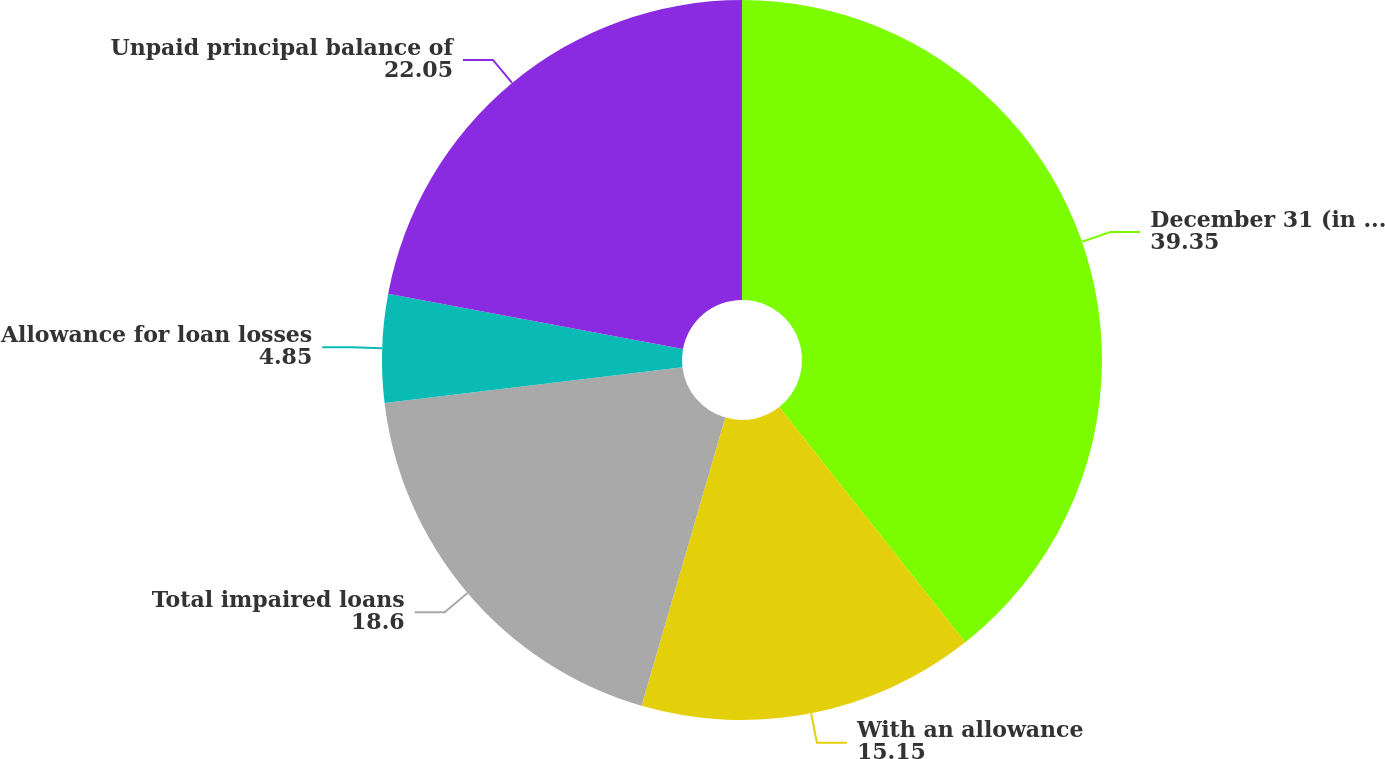<chart> <loc_0><loc_0><loc_500><loc_500><pie_chart><fcel>December 31 (in millions)<fcel>With an allowance<fcel>Total impaired loans<fcel>Allowance for loan losses<fcel>Unpaid principal balance of<nl><fcel>39.35%<fcel>15.15%<fcel>18.6%<fcel>4.85%<fcel>22.05%<nl></chart> 